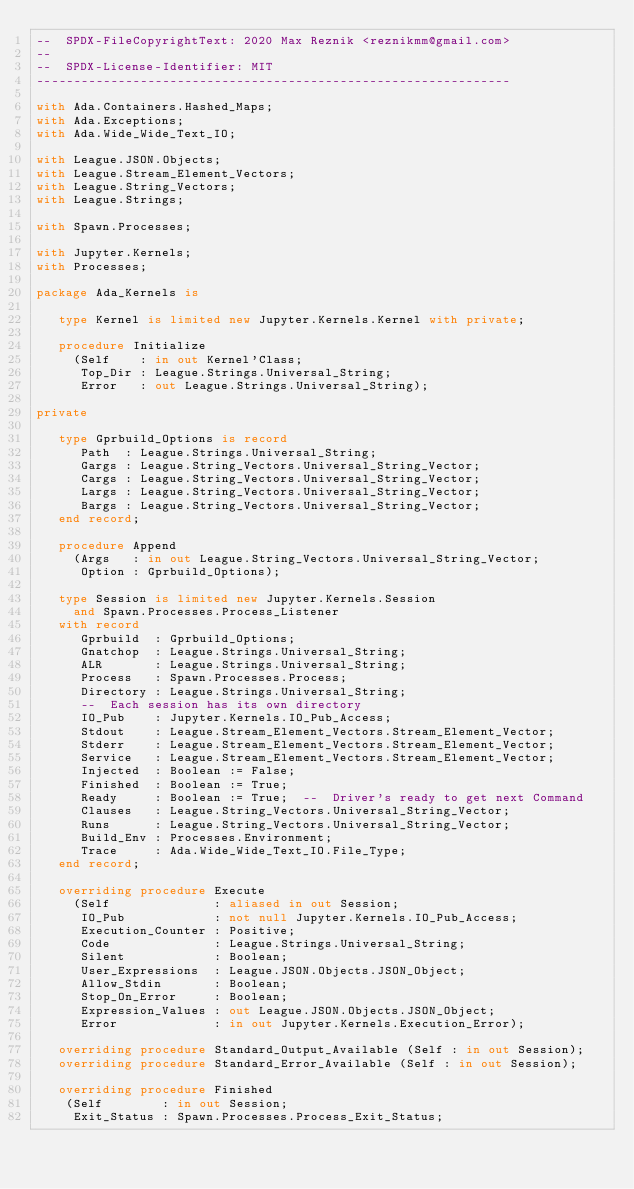Convert code to text. <code><loc_0><loc_0><loc_500><loc_500><_Ada_>--  SPDX-FileCopyrightText: 2020 Max Reznik <reznikmm@gmail.com>
--
--  SPDX-License-Identifier: MIT
----------------------------------------------------------------

with Ada.Containers.Hashed_Maps;
with Ada.Exceptions;
with Ada.Wide_Wide_Text_IO;

with League.JSON.Objects;
with League.Stream_Element_Vectors;
with League.String_Vectors;
with League.Strings;

with Spawn.Processes;

with Jupyter.Kernels;
with Processes;

package Ada_Kernels is

   type Kernel is limited new Jupyter.Kernels.Kernel with private;

   procedure Initialize
     (Self    : in out Kernel'Class;
      Top_Dir : League.Strings.Universal_String;
      Error   : out League.Strings.Universal_String);

private

   type Gprbuild_Options is record
      Path  : League.Strings.Universal_String;
      Gargs : League.String_Vectors.Universal_String_Vector;
      Cargs : League.String_Vectors.Universal_String_Vector;
      Largs : League.String_Vectors.Universal_String_Vector;
      Bargs : League.String_Vectors.Universal_String_Vector;
   end record;

   procedure Append
     (Args   : in out League.String_Vectors.Universal_String_Vector;
      Option : Gprbuild_Options);

   type Session is limited new Jupyter.Kernels.Session
     and Spawn.Processes.Process_Listener
   with record
      Gprbuild  : Gprbuild_Options;
      Gnatchop  : League.Strings.Universal_String;
      ALR       : League.Strings.Universal_String;
      Process   : Spawn.Processes.Process;
      Directory : League.Strings.Universal_String;
      --  Each session has its own directory
      IO_Pub    : Jupyter.Kernels.IO_Pub_Access;
      Stdout    : League.Stream_Element_Vectors.Stream_Element_Vector;
      Stderr    : League.Stream_Element_Vectors.Stream_Element_Vector;
      Service   : League.Stream_Element_Vectors.Stream_Element_Vector;
      Injected  : Boolean := False;
      Finished  : Boolean := True;
      Ready     : Boolean := True;  --  Driver's ready to get next Command
      Clauses   : League.String_Vectors.Universal_String_Vector;
      Runs      : League.String_Vectors.Universal_String_Vector;
      Build_Env : Processes.Environment;
      Trace     : Ada.Wide_Wide_Text_IO.File_Type;
   end record;

   overriding procedure Execute
     (Self              : aliased in out Session;
      IO_Pub            : not null Jupyter.Kernels.IO_Pub_Access;
      Execution_Counter : Positive;
      Code              : League.Strings.Universal_String;
      Silent            : Boolean;
      User_Expressions  : League.JSON.Objects.JSON_Object;
      Allow_Stdin       : Boolean;
      Stop_On_Error     : Boolean;
      Expression_Values : out League.JSON.Objects.JSON_Object;
      Error             : in out Jupyter.Kernels.Execution_Error);

   overriding procedure Standard_Output_Available (Self : in out Session);
   overriding procedure Standard_Error_Available (Self : in out Session);

   overriding procedure Finished
    (Self        : in out Session;
     Exit_Status : Spawn.Processes.Process_Exit_Status;</code> 